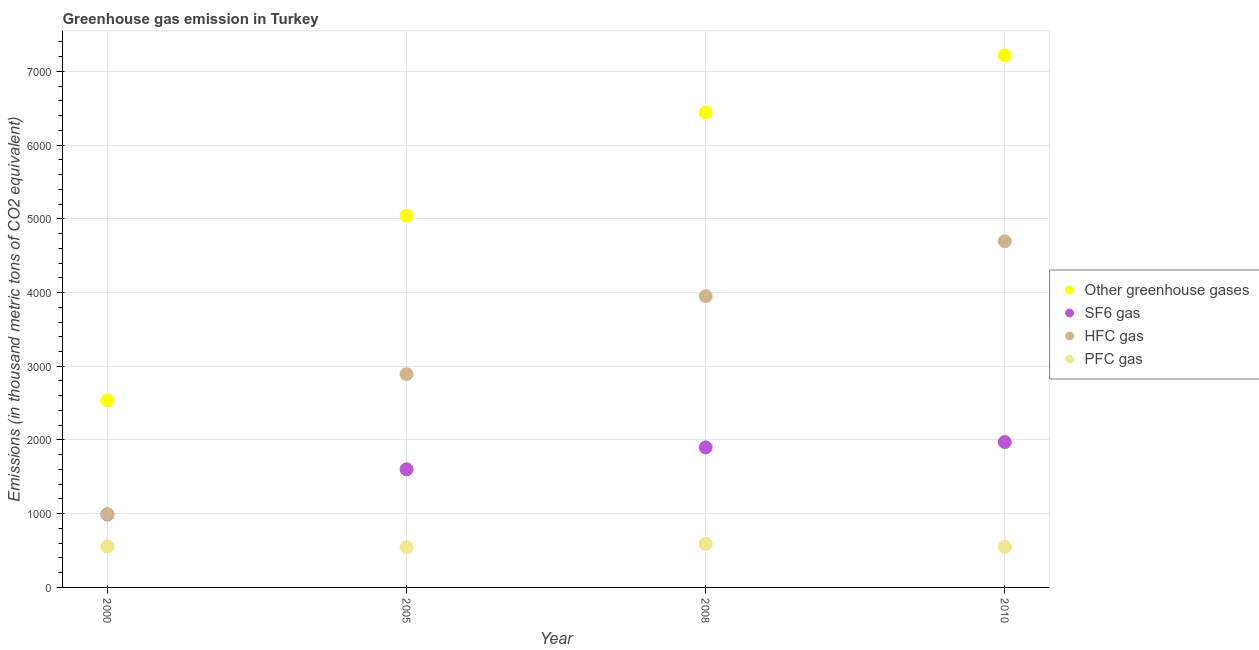What is the emission of pfc gas in 2008?
Keep it short and to the point. 591.4. Across all years, what is the maximum emission of pfc gas?
Your response must be concise. 591.4. Across all years, what is the minimum emission of hfc gas?
Your response must be concise. 994.4. What is the total emission of pfc gas in the graph?
Ensure brevity in your answer.  2241.2. What is the difference between the emission of greenhouse gases in 2005 and that in 2008?
Your response must be concise. -1399.7. What is the difference between the emission of sf6 gas in 2000 and the emission of pfc gas in 2008?
Your response must be concise. 397.8. What is the average emission of hfc gas per year?
Keep it short and to the point. 3133.35. In the year 2010, what is the difference between the emission of hfc gas and emission of sf6 gas?
Keep it short and to the point. 2723. In how many years, is the emission of pfc gas greater than 6000 thousand metric tons?
Offer a very short reply. 0. What is the ratio of the emission of greenhouse gases in 2008 to that in 2010?
Keep it short and to the point. 0.89. Is the emission of hfc gas in 2008 less than that in 2010?
Keep it short and to the point. Yes. What is the difference between the highest and the second highest emission of hfc gas?
Make the answer very short. 744.2. What is the difference between the highest and the lowest emission of pfc gas?
Provide a short and direct response. 45.5. In how many years, is the emission of sf6 gas greater than the average emission of sf6 gas taken over all years?
Your answer should be very brief. 2. Is it the case that in every year, the sum of the emission of greenhouse gases and emission of sf6 gas is greater than the emission of hfc gas?
Your response must be concise. Yes. Is the emission of hfc gas strictly greater than the emission of pfc gas over the years?
Offer a very short reply. Yes. Is the emission of greenhouse gases strictly less than the emission of hfc gas over the years?
Your answer should be very brief. No. How many years are there in the graph?
Give a very brief answer. 4. Are the values on the major ticks of Y-axis written in scientific E-notation?
Keep it short and to the point. No. Does the graph contain grids?
Your answer should be compact. Yes. How are the legend labels stacked?
Your answer should be very brief. Vertical. What is the title of the graph?
Offer a very short reply. Greenhouse gas emission in Turkey. Does "UNRWA" appear as one of the legend labels in the graph?
Your response must be concise. No. What is the label or title of the X-axis?
Your answer should be compact. Year. What is the label or title of the Y-axis?
Offer a very short reply. Emissions (in thousand metric tons of CO2 equivalent). What is the Emissions (in thousand metric tons of CO2 equivalent) in Other greenhouse gases in 2000?
Your answer should be very brief. 2538.5. What is the Emissions (in thousand metric tons of CO2 equivalent) of SF6 gas in 2000?
Keep it short and to the point. 989.2. What is the Emissions (in thousand metric tons of CO2 equivalent) of HFC gas in 2000?
Give a very brief answer. 994.4. What is the Emissions (in thousand metric tons of CO2 equivalent) in PFC gas in 2000?
Provide a short and direct response. 554.9. What is the Emissions (in thousand metric tons of CO2 equivalent) in Other greenhouse gases in 2005?
Offer a terse response. 5041.3. What is the Emissions (in thousand metric tons of CO2 equivalent) in SF6 gas in 2005?
Make the answer very short. 1602.2. What is the Emissions (in thousand metric tons of CO2 equivalent) of HFC gas in 2005?
Your answer should be compact. 2893.2. What is the Emissions (in thousand metric tons of CO2 equivalent) of PFC gas in 2005?
Keep it short and to the point. 545.9. What is the Emissions (in thousand metric tons of CO2 equivalent) in Other greenhouse gases in 2008?
Your answer should be compact. 6441. What is the Emissions (in thousand metric tons of CO2 equivalent) of SF6 gas in 2008?
Offer a terse response. 1898.8. What is the Emissions (in thousand metric tons of CO2 equivalent) in HFC gas in 2008?
Offer a very short reply. 3950.8. What is the Emissions (in thousand metric tons of CO2 equivalent) of PFC gas in 2008?
Keep it short and to the point. 591.4. What is the Emissions (in thousand metric tons of CO2 equivalent) in Other greenhouse gases in 2010?
Make the answer very short. 7216. What is the Emissions (in thousand metric tons of CO2 equivalent) of SF6 gas in 2010?
Your response must be concise. 1972. What is the Emissions (in thousand metric tons of CO2 equivalent) in HFC gas in 2010?
Offer a terse response. 4695. What is the Emissions (in thousand metric tons of CO2 equivalent) of PFC gas in 2010?
Provide a short and direct response. 549. Across all years, what is the maximum Emissions (in thousand metric tons of CO2 equivalent) of Other greenhouse gases?
Ensure brevity in your answer.  7216. Across all years, what is the maximum Emissions (in thousand metric tons of CO2 equivalent) of SF6 gas?
Offer a very short reply. 1972. Across all years, what is the maximum Emissions (in thousand metric tons of CO2 equivalent) in HFC gas?
Your response must be concise. 4695. Across all years, what is the maximum Emissions (in thousand metric tons of CO2 equivalent) in PFC gas?
Make the answer very short. 591.4. Across all years, what is the minimum Emissions (in thousand metric tons of CO2 equivalent) in Other greenhouse gases?
Give a very brief answer. 2538.5. Across all years, what is the minimum Emissions (in thousand metric tons of CO2 equivalent) in SF6 gas?
Your answer should be very brief. 989.2. Across all years, what is the minimum Emissions (in thousand metric tons of CO2 equivalent) in HFC gas?
Provide a succinct answer. 994.4. Across all years, what is the minimum Emissions (in thousand metric tons of CO2 equivalent) in PFC gas?
Provide a short and direct response. 545.9. What is the total Emissions (in thousand metric tons of CO2 equivalent) in Other greenhouse gases in the graph?
Give a very brief answer. 2.12e+04. What is the total Emissions (in thousand metric tons of CO2 equivalent) in SF6 gas in the graph?
Offer a terse response. 6462.2. What is the total Emissions (in thousand metric tons of CO2 equivalent) in HFC gas in the graph?
Make the answer very short. 1.25e+04. What is the total Emissions (in thousand metric tons of CO2 equivalent) of PFC gas in the graph?
Your response must be concise. 2241.2. What is the difference between the Emissions (in thousand metric tons of CO2 equivalent) in Other greenhouse gases in 2000 and that in 2005?
Provide a succinct answer. -2502.8. What is the difference between the Emissions (in thousand metric tons of CO2 equivalent) of SF6 gas in 2000 and that in 2005?
Give a very brief answer. -613. What is the difference between the Emissions (in thousand metric tons of CO2 equivalent) in HFC gas in 2000 and that in 2005?
Give a very brief answer. -1898.8. What is the difference between the Emissions (in thousand metric tons of CO2 equivalent) of PFC gas in 2000 and that in 2005?
Offer a very short reply. 9. What is the difference between the Emissions (in thousand metric tons of CO2 equivalent) in Other greenhouse gases in 2000 and that in 2008?
Offer a very short reply. -3902.5. What is the difference between the Emissions (in thousand metric tons of CO2 equivalent) in SF6 gas in 2000 and that in 2008?
Provide a short and direct response. -909.6. What is the difference between the Emissions (in thousand metric tons of CO2 equivalent) in HFC gas in 2000 and that in 2008?
Offer a very short reply. -2956.4. What is the difference between the Emissions (in thousand metric tons of CO2 equivalent) in PFC gas in 2000 and that in 2008?
Provide a succinct answer. -36.5. What is the difference between the Emissions (in thousand metric tons of CO2 equivalent) of Other greenhouse gases in 2000 and that in 2010?
Your response must be concise. -4677.5. What is the difference between the Emissions (in thousand metric tons of CO2 equivalent) of SF6 gas in 2000 and that in 2010?
Ensure brevity in your answer.  -982.8. What is the difference between the Emissions (in thousand metric tons of CO2 equivalent) in HFC gas in 2000 and that in 2010?
Make the answer very short. -3700.6. What is the difference between the Emissions (in thousand metric tons of CO2 equivalent) of PFC gas in 2000 and that in 2010?
Provide a succinct answer. 5.9. What is the difference between the Emissions (in thousand metric tons of CO2 equivalent) in Other greenhouse gases in 2005 and that in 2008?
Provide a short and direct response. -1399.7. What is the difference between the Emissions (in thousand metric tons of CO2 equivalent) of SF6 gas in 2005 and that in 2008?
Keep it short and to the point. -296.6. What is the difference between the Emissions (in thousand metric tons of CO2 equivalent) in HFC gas in 2005 and that in 2008?
Offer a very short reply. -1057.6. What is the difference between the Emissions (in thousand metric tons of CO2 equivalent) in PFC gas in 2005 and that in 2008?
Offer a very short reply. -45.5. What is the difference between the Emissions (in thousand metric tons of CO2 equivalent) of Other greenhouse gases in 2005 and that in 2010?
Your response must be concise. -2174.7. What is the difference between the Emissions (in thousand metric tons of CO2 equivalent) of SF6 gas in 2005 and that in 2010?
Offer a terse response. -369.8. What is the difference between the Emissions (in thousand metric tons of CO2 equivalent) of HFC gas in 2005 and that in 2010?
Keep it short and to the point. -1801.8. What is the difference between the Emissions (in thousand metric tons of CO2 equivalent) of Other greenhouse gases in 2008 and that in 2010?
Offer a very short reply. -775. What is the difference between the Emissions (in thousand metric tons of CO2 equivalent) of SF6 gas in 2008 and that in 2010?
Your response must be concise. -73.2. What is the difference between the Emissions (in thousand metric tons of CO2 equivalent) of HFC gas in 2008 and that in 2010?
Provide a short and direct response. -744.2. What is the difference between the Emissions (in thousand metric tons of CO2 equivalent) in PFC gas in 2008 and that in 2010?
Your response must be concise. 42.4. What is the difference between the Emissions (in thousand metric tons of CO2 equivalent) of Other greenhouse gases in 2000 and the Emissions (in thousand metric tons of CO2 equivalent) of SF6 gas in 2005?
Keep it short and to the point. 936.3. What is the difference between the Emissions (in thousand metric tons of CO2 equivalent) of Other greenhouse gases in 2000 and the Emissions (in thousand metric tons of CO2 equivalent) of HFC gas in 2005?
Your answer should be very brief. -354.7. What is the difference between the Emissions (in thousand metric tons of CO2 equivalent) of Other greenhouse gases in 2000 and the Emissions (in thousand metric tons of CO2 equivalent) of PFC gas in 2005?
Offer a terse response. 1992.6. What is the difference between the Emissions (in thousand metric tons of CO2 equivalent) in SF6 gas in 2000 and the Emissions (in thousand metric tons of CO2 equivalent) in HFC gas in 2005?
Provide a short and direct response. -1904. What is the difference between the Emissions (in thousand metric tons of CO2 equivalent) of SF6 gas in 2000 and the Emissions (in thousand metric tons of CO2 equivalent) of PFC gas in 2005?
Your response must be concise. 443.3. What is the difference between the Emissions (in thousand metric tons of CO2 equivalent) of HFC gas in 2000 and the Emissions (in thousand metric tons of CO2 equivalent) of PFC gas in 2005?
Your answer should be compact. 448.5. What is the difference between the Emissions (in thousand metric tons of CO2 equivalent) in Other greenhouse gases in 2000 and the Emissions (in thousand metric tons of CO2 equivalent) in SF6 gas in 2008?
Your answer should be compact. 639.7. What is the difference between the Emissions (in thousand metric tons of CO2 equivalent) in Other greenhouse gases in 2000 and the Emissions (in thousand metric tons of CO2 equivalent) in HFC gas in 2008?
Provide a short and direct response. -1412.3. What is the difference between the Emissions (in thousand metric tons of CO2 equivalent) in Other greenhouse gases in 2000 and the Emissions (in thousand metric tons of CO2 equivalent) in PFC gas in 2008?
Ensure brevity in your answer.  1947.1. What is the difference between the Emissions (in thousand metric tons of CO2 equivalent) in SF6 gas in 2000 and the Emissions (in thousand metric tons of CO2 equivalent) in HFC gas in 2008?
Give a very brief answer. -2961.6. What is the difference between the Emissions (in thousand metric tons of CO2 equivalent) in SF6 gas in 2000 and the Emissions (in thousand metric tons of CO2 equivalent) in PFC gas in 2008?
Provide a short and direct response. 397.8. What is the difference between the Emissions (in thousand metric tons of CO2 equivalent) in HFC gas in 2000 and the Emissions (in thousand metric tons of CO2 equivalent) in PFC gas in 2008?
Give a very brief answer. 403. What is the difference between the Emissions (in thousand metric tons of CO2 equivalent) of Other greenhouse gases in 2000 and the Emissions (in thousand metric tons of CO2 equivalent) of SF6 gas in 2010?
Your answer should be compact. 566.5. What is the difference between the Emissions (in thousand metric tons of CO2 equivalent) of Other greenhouse gases in 2000 and the Emissions (in thousand metric tons of CO2 equivalent) of HFC gas in 2010?
Offer a terse response. -2156.5. What is the difference between the Emissions (in thousand metric tons of CO2 equivalent) in Other greenhouse gases in 2000 and the Emissions (in thousand metric tons of CO2 equivalent) in PFC gas in 2010?
Your answer should be compact. 1989.5. What is the difference between the Emissions (in thousand metric tons of CO2 equivalent) in SF6 gas in 2000 and the Emissions (in thousand metric tons of CO2 equivalent) in HFC gas in 2010?
Offer a very short reply. -3705.8. What is the difference between the Emissions (in thousand metric tons of CO2 equivalent) in SF6 gas in 2000 and the Emissions (in thousand metric tons of CO2 equivalent) in PFC gas in 2010?
Provide a succinct answer. 440.2. What is the difference between the Emissions (in thousand metric tons of CO2 equivalent) in HFC gas in 2000 and the Emissions (in thousand metric tons of CO2 equivalent) in PFC gas in 2010?
Give a very brief answer. 445.4. What is the difference between the Emissions (in thousand metric tons of CO2 equivalent) of Other greenhouse gases in 2005 and the Emissions (in thousand metric tons of CO2 equivalent) of SF6 gas in 2008?
Provide a succinct answer. 3142.5. What is the difference between the Emissions (in thousand metric tons of CO2 equivalent) of Other greenhouse gases in 2005 and the Emissions (in thousand metric tons of CO2 equivalent) of HFC gas in 2008?
Ensure brevity in your answer.  1090.5. What is the difference between the Emissions (in thousand metric tons of CO2 equivalent) in Other greenhouse gases in 2005 and the Emissions (in thousand metric tons of CO2 equivalent) in PFC gas in 2008?
Ensure brevity in your answer.  4449.9. What is the difference between the Emissions (in thousand metric tons of CO2 equivalent) in SF6 gas in 2005 and the Emissions (in thousand metric tons of CO2 equivalent) in HFC gas in 2008?
Provide a short and direct response. -2348.6. What is the difference between the Emissions (in thousand metric tons of CO2 equivalent) in SF6 gas in 2005 and the Emissions (in thousand metric tons of CO2 equivalent) in PFC gas in 2008?
Your answer should be very brief. 1010.8. What is the difference between the Emissions (in thousand metric tons of CO2 equivalent) of HFC gas in 2005 and the Emissions (in thousand metric tons of CO2 equivalent) of PFC gas in 2008?
Offer a terse response. 2301.8. What is the difference between the Emissions (in thousand metric tons of CO2 equivalent) of Other greenhouse gases in 2005 and the Emissions (in thousand metric tons of CO2 equivalent) of SF6 gas in 2010?
Provide a short and direct response. 3069.3. What is the difference between the Emissions (in thousand metric tons of CO2 equivalent) of Other greenhouse gases in 2005 and the Emissions (in thousand metric tons of CO2 equivalent) of HFC gas in 2010?
Offer a very short reply. 346.3. What is the difference between the Emissions (in thousand metric tons of CO2 equivalent) in Other greenhouse gases in 2005 and the Emissions (in thousand metric tons of CO2 equivalent) in PFC gas in 2010?
Make the answer very short. 4492.3. What is the difference between the Emissions (in thousand metric tons of CO2 equivalent) of SF6 gas in 2005 and the Emissions (in thousand metric tons of CO2 equivalent) of HFC gas in 2010?
Ensure brevity in your answer.  -3092.8. What is the difference between the Emissions (in thousand metric tons of CO2 equivalent) in SF6 gas in 2005 and the Emissions (in thousand metric tons of CO2 equivalent) in PFC gas in 2010?
Provide a short and direct response. 1053.2. What is the difference between the Emissions (in thousand metric tons of CO2 equivalent) in HFC gas in 2005 and the Emissions (in thousand metric tons of CO2 equivalent) in PFC gas in 2010?
Offer a very short reply. 2344.2. What is the difference between the Emissions (in thousand metric tons of CO2 equivalent) of Other greenhouse gases in 2008 and the Emissions (in thousand metric tons of CO2 equivalent) of SF6 gas in 2010?
Provide a succinct answer. 4469. What is the difference between the Emissions (in thousand metric tons of CO2 equivalent) of Other greenhouse gases in 2008 and the Emissions (in thousand metric tons of CO2 equivalent) of HFC gas in 2010?
Your response must be concise. 1746. What is the difference between the Emissions (in thousand metric tons of CO2 equivalent) of Other greenhouse gases in 2008 and the Emissions (in thousand metric tons of CO2 equivalent) of PFC gas in 2010?
Your answer should be very brief. 5892. What is the difference between the Emissions (in thousand metric tons of CO2 equivalent) in SF6 gas in 2008 and the Emissions (in thousand metric tons of CO2 equivalent) in HFC gas in 2010?
Provide a succinct answer. -2796.2. What is the difference between the Emissions (in thousand metric tons of CO2 equivalent) of SF6 gas in 2008 and the Emissions (in thousand metric tons of CO2 equivalent) of PFC gas in 2010?
Make the answer very short. 1349.8. What is the difference between the Emissions (in thousand metric tons of CO2 equivalent) in HFC gas in 2008 and the Emissions (in thousand metric tons of CO2 equivalent) in PFC gas in 2010?
Give a very brief answer. 3401.8. What is the average Emissions (in thousand metric tons of CO2 equivalent) in Other greenhouse gases per year?
Your answer should be compact. 5309.2. What is the average Emissions (in thousand metric tons of CO2 equivalent) of SF6 gas per year?
Give a very brief answer. 1615.55. What is the average Emissions (in thousand metric tons of CO2 equivalent) of HFC gas per year?
Give a very brief answer. 3133.35. What is the average Emissions (in thousand metric tons of CO2 equivalent) of PFC gas per year?
Your response must be concise. 560.3. In the year 2000, what is the difference between the Emissions (in thousand metric tons of CO2 equivalent) in Other greenhouse gases and Emissions (in thousand metric tons of CO2 equivalent) in SF6 gas?
Give a very brief answer. 1549.3. In the year 2000, what is the difference between the Emissions (in thousand metric tons of CO2 equivalent) of Other greenhouse gases and Emissions (in thousand metric tons of CO2 equivalent) of HFC gas?
Provide a succinct answer. 1544.1. In the year 2000, what is the difference between the Emissions (in thousand metric tons of CO2 equivalent) in Other greenhouse gases and Emissions (in thousand metric tons of CO2 equivalent) in PFC gas?
Your answer should be very brief. 1983.6. In the year 2000, what is the difference between the Emissions (in thousand metric tons of CO2 equivalent) in SF6 gas and Emissions (in thousand metric tons of CO2 equivalent) in PFC gas?
Make the answer very short. 434.3. In the year 2000, what is the difference between the Emissions (in thousand metric tons of CO2 equivalent) in HFC gas and Emissions (in thousand metric tons of CO2 equivalent) in PFC gas?
Make the answer very short. 439.5. In the year 2005, what is the difference between the Emissions (in thousand metric tons of CO2 equivalent) in Other greenhouse gases and Emissions (in thousand metric tons of CO2 equivalent) in SF6 gas?
Give a very brief answer. 3439.1. In the year 2005, what is the difference between the Emissions (in thousand metric tons of CO2 equivalent) of Other greenhouse gases and Emissions (in thousand metric tons of CO2 equivalent) of HFC gas?
Offer a terse response. 2148.1. In the year 2005, what is the difference between the Emissions (in thousand metric tons of CO2 equivalent) in Other greenhouse gases and Emissions (in thousand metric tons of CO2 equivalent) in PFC gas?
Keep it short and to the point. 4495.4. In the year 2005, what is the difference between the Emissions (in thousand metric tons of CO2 equivalent) of SF6 gas and Emissions (in thousand metric tons of CO2 equivalent) of HFC gas?
Provide a short and direct response. -1291. In the year 2005, what is the difference between the Emissions (in thousand metric tons of CO2 equivalent) in SF6 gas and Emissions (in thousand metric tons of CO2 equivalent) in PFC gas?
Offer a very short reply. 1056.3. In the year 2005, what is the difference between the Emissions (in thousand metric tons of CO2 equivalent) in HFC gas and Emissions (in thousand metric tons of CO2 equivalent) in PFC gas?
Offer a very short reply. 2347.3. In the year 2008, what is the difference between the Emissions (in thousand metric tons of CO2 equivalent) of Other greenhouse gases and Emissions (in thousand metric tons of CO2 equivalent) of SF6 gas?
Your answer should be compact. 4542.2. In the year 2008, what is the difference between the Emissions (in thousand metric tons of CO2 equivalent) of Other greenhouse gases and Emissions (in thousand metric tons of CO2 equivalent) of HFC gas?
Make the answer very short. 2490.2. In the year 2008, what is the difference between the Emissions (in thousand metric tons of CO2 equivalent) of Other greenhouse gases and Emissions (in thousand metric tons of CO2 equivalent) of PFC gas?
Offer a terse response. 5849.6. In the year 2008, what is the difference between the Emissions (in thousand metric tons of CO2 equivalent) in SF6 gas and Emissions (in thousand metric tons of CO2 equivalent) in HFC gas?
Keep it short and to the point. -2052. In the year 2008, what is the difference between the Emissions (in thousand metric tons of CO2 equivalent) in SF6 gas and Emissions (in thousand metric tons of CO2 equivalent) in PFC gas?
Make the answer very short. 1307.4. In the year 2008, what is the difference between the Emissions (in thousand metric tons of CO2 equivalent) in HFC gas and Emissions (in thousand metric tons of CO2 equivalent) in PFC gas?
Provide a succinct answer. 3359.4. In the year 2010, what is the difference between the Emissions (in thousand metric tons of CO2 equivalent) in Other greenhouse gases and Emissions (in thousand metric tons of CO2 equivalent) in SF6 gas?
Offer a terse response. 5244. In the year 2010, what is the difference between the Emissions (in thousand metric tons of CO2 equivalent) of Other greenhouse gases and Emissions (in thousand metric tons of CO2 equivalent) of HFC gas?
Ensure brevity in your answer.  2521. In the year 2010, what is the difference between the Emissions (in thousand metric tons of CO2 equivalent) of Other greenhouse gases and Emissions (in thousand metric tons of CO2 equivalent) of PFC gas?
Make the answer very short. 6667. In the year 2010, what is the difference between the Emissions (in thousand metric tons of CO2 equivalent) in SF6 gas and Emissions (in thousand metric tons of CO2 equivalent) in HFC gas?
Give a very brief answer. -2723. In the year 2010, what is the difference between the Emissions (in thousand metric tons of CO2 equivalent) of SF6 gas and Emissions (in thousand metric tons of CO2 equivalent) of PFC gas?
Keep it short and to the point. 1423. In the year 2010, what is the difference between the Emissions (in thousand metric tons of CO2 equivalent) in HFC gas and Emissions (in thousand metric tons of CO2 equivalent) in PFC gas?
Provide a short and direct response. 4146. What is the ratio of the Emissions (in thousand metric tons of CO2 equivalent) in Other greenhouse gases in 2000 to that in 2005?
Your answer should be very brief. 0.5. What is the ratio of the Emissions (in thousand metric tons of CO2 equivalent) of SF6 gas in 2000 to that in 2005?
Keep it short and to the point. 0.62. What is the ratio of the Emissions (in thousand metric tons of CO2 equivalent) in HFC gas in 2000 to that in 2005?
Provide a short and direct response. 0.34. What is the ratio of the Emissions (in thousand metric tons of CO2 equivalent) in PFC gas in 2000 to that in 2005?
Provide a succinct answer. 1.02. What is the ratio of the Emissions (in thousand metric tons of CO2 equivalent) of Other greenhouse gases in 2000 to that in 2008?
Your response must be concise. 0.39. What is the ratio of the Emissions (in thousand metric tons of CO2 equivalent) in SF6 gas in 2000 to that in 2008?
Offer a terse response. 0.52. What is the ratio of the Emissions (in thousand metric tons of CO2 equivalent) in HFC gas in 2000 to that in 2008?
Ensure brevity in your answer.  0.25. What is the ratio of the Emissions (in thousand metric tons of CO2 equivalent) of PFC gas in 2000 to that in 2008?
Your response must be concise. 0.94. What is the ratio of the Emissions (in thousand metric tons of CO2 equivalent) of Other greenhouse gases in 2000 to that in 2010?
Your response must be concise. 0.35. What is the ratio of the Emissions (in thousand metric tons of CO2 equivalent) in SF6 gas in 2000 to that in 2010?
Keep it short and to the point. 0.5. What is the ratio of the Emissions (in thousand metric tons of CO2 equivalent) in HFC gas in 2000 to that in 2010?
Offer a very short reply. 0.21. What is the ratio of the Emissions (in thousand metric tons of CO2 equivalent) of PFC gas in 2000 to that in 2010?
Keep it short and to the point. 1.01. What is the ratio of the Emissions (in thousand metric tons of CO2 equivalent) in Other greenhouse gases in 2005 to that in 2008?
Offer a terse response. 0.78. What is the ratio of the Emissions (in thousand metric tons of CO2 equivalent) of SF6 gas in 2005 to that in 2008?
Offer a very short reply. 0.84. What is the ratio of the Emissions (in thousand metric tons of CO2 equivalent) in HFC gas in 2005 to that in 2008?
Offer a terse response. 0.73. What is the ratio of the Emissions (in thousand metric tons of CO2 equivalent) in Other greenhouse gases in 2005 to that in 2010?
Make the answer very short. 0.7. What is the ratio of the Emissions (in thousand metric tons of CO2 equivalent) in SF6 gas in 2005 to that in 2010?
Your response must be concise. 0.81. What is the ratio of the Emissions (in thousand metric tons of CO2 equivalent) of HFC gas in 2005 to that in 2010?
Give a very brief answer. 0.62. What is the ratio of the Emissions (in thousand metric tons of CO2 equivalent) in Other greenhouse gases in 2008 to that in 2010?
Offer a terse response. 0.89. What is the ratio of the Emissions (in thousand metric tons of CO2 equivalent) of SF6 gas in 2008 to that in 2010?
Your response must be concise. 0.96. What is the ratio of the Emissions (in thousand metric tons of CO2 equivalent) in HFC gas in 2008 to that in 2010?
Provide a succinct answer. 0.84. What is the ratio of the Emissions (in thousand metric tons of CO2 equivalent) of PFC gas in 2008 to that in 2010?
Make the answer very short. 1.08. What is the difference between the highest and the second highest Emissions (in thousand metric tons of CO2 equivalent) in Other greenhouse gases?
Offer a terse response. 775. What is the difference between the highest and the second highest Emissions (in thousand metric tons of CO2 equivalent) of SF6 gas?
Provide a short and direct response. 73.2. What is the difference between the highest and the second highest Emissions (in thousand metric tons of CO2 equivalent) in HFC gas?
Provide a short and direct response. 744.2. What is the difference between the highest and the second highest Emissions (in thousand metric tons of CO2 equivalent) in PFC gas?
Keep it short and to the point. 36.5. What is the difference between the highest and the lowest Emissions (in thousand metric tons of CO2 equivalent) in Other greenhouse gases?
Provide a short and direct response. 4677.5. What is the difference between the highest and the lowest Emissions (in thousand metric tons of CO2 equivalent) of SF6 gas?
Give a very brief answer. 982.8. What is the difference between the highest and the lowest Emissions (in thousand metric tons of CO2 equivalent) in HFC gas?
Keep it short and to the point. 3700.6. What is the difference between the highest and the lowest Emissions (in thousand metric tons of CO2 equivalent) in PFC gas?
Provide a short and direct response. 45.5. 